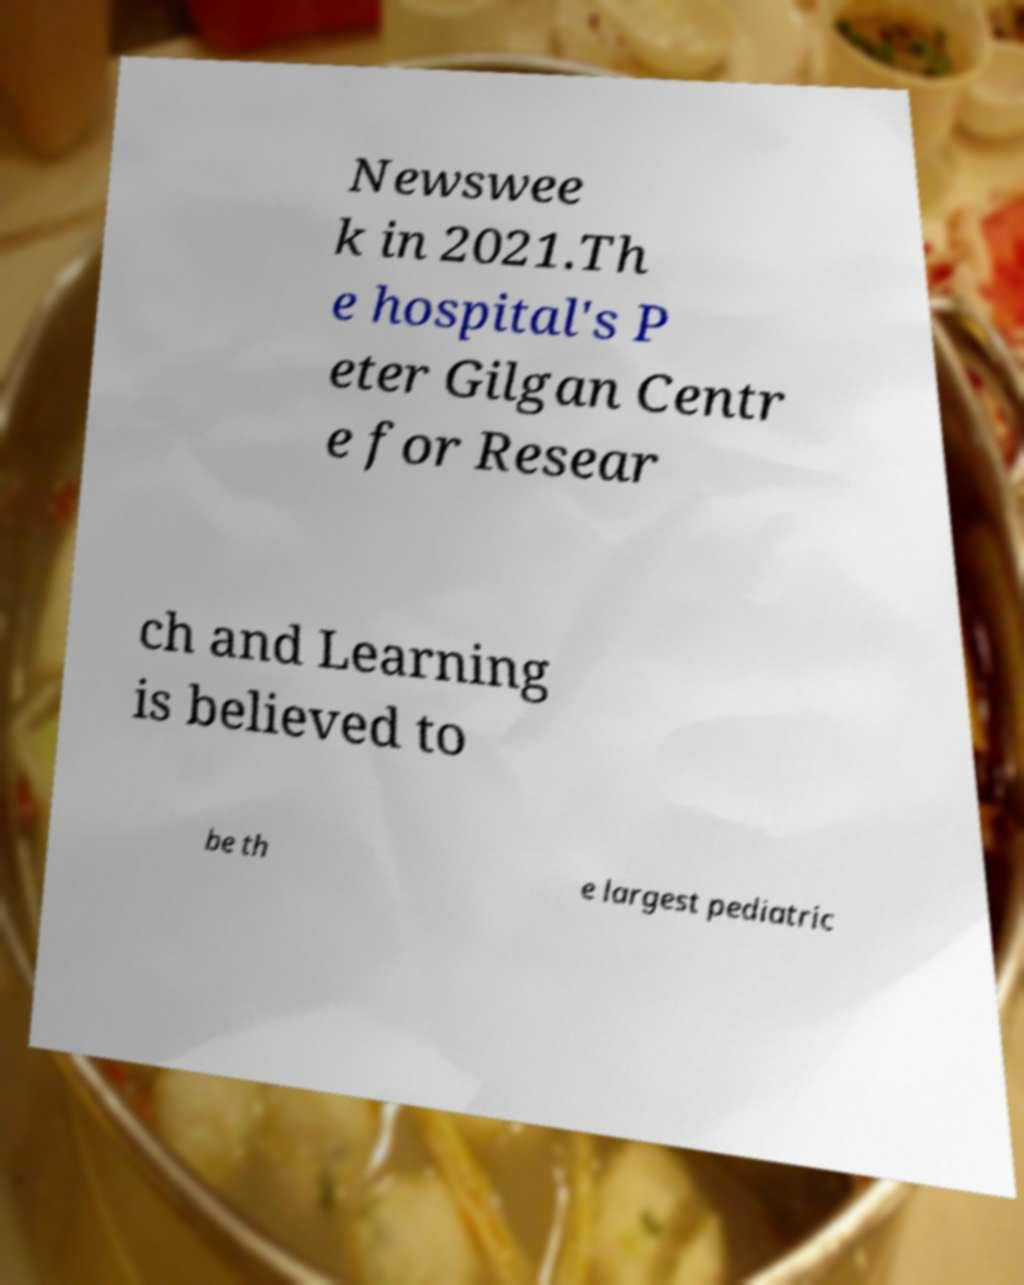There's text embedded in this image that I need extracted. Can you transcribe it verbatim? Newswee k in 2021.Th e hospital's P eter Gilgan Centr e for Resear ch and Learning is believed to be th e largest pediatric 